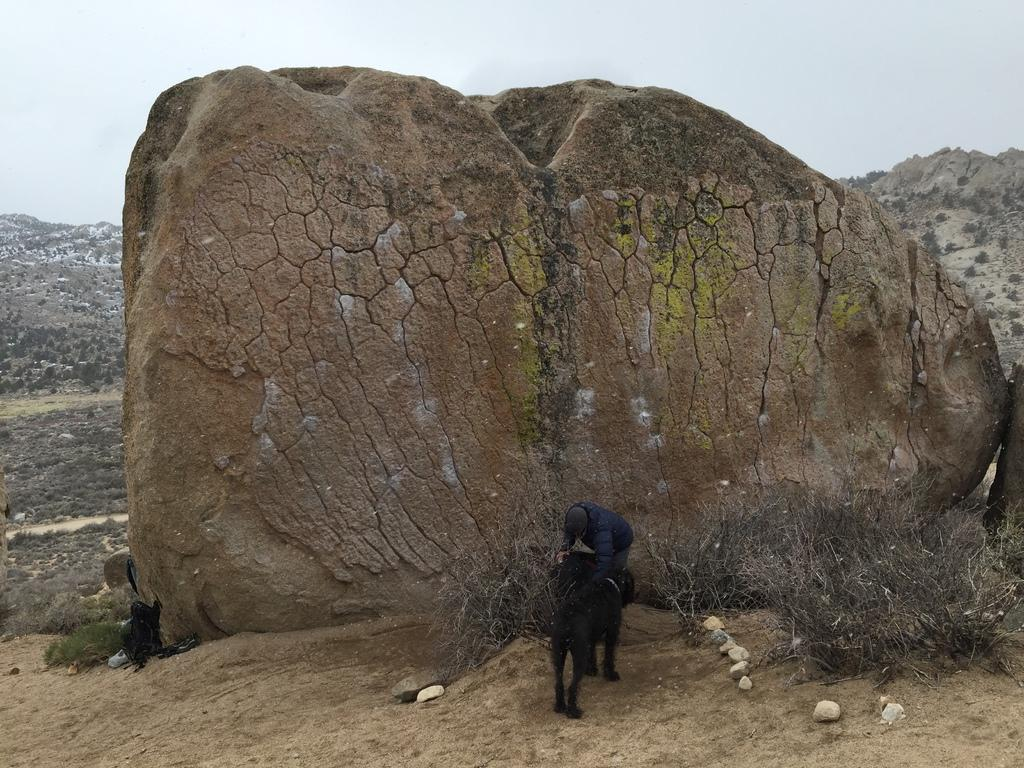What is located in the foreground of the image? There is a dog in the foreground of the image. Can you identify any other living beings in the image? Yes, there is a person in the image. What type of vegetation is present on the ground in the image? There are plants and shrubs on the ground in the image. What is the location of the image? The location is a hill. What can be seen in the background of the image? There are trees, hills, and the sky visible in the background of the image. What type of coal is being mined by the person in the image? There is no coal or mining activity present in the image. Is the person in the image a porter carrying a load? The image does not provide any information about the person's occupation or the presence of a load, so it cannot be determined from the image. 